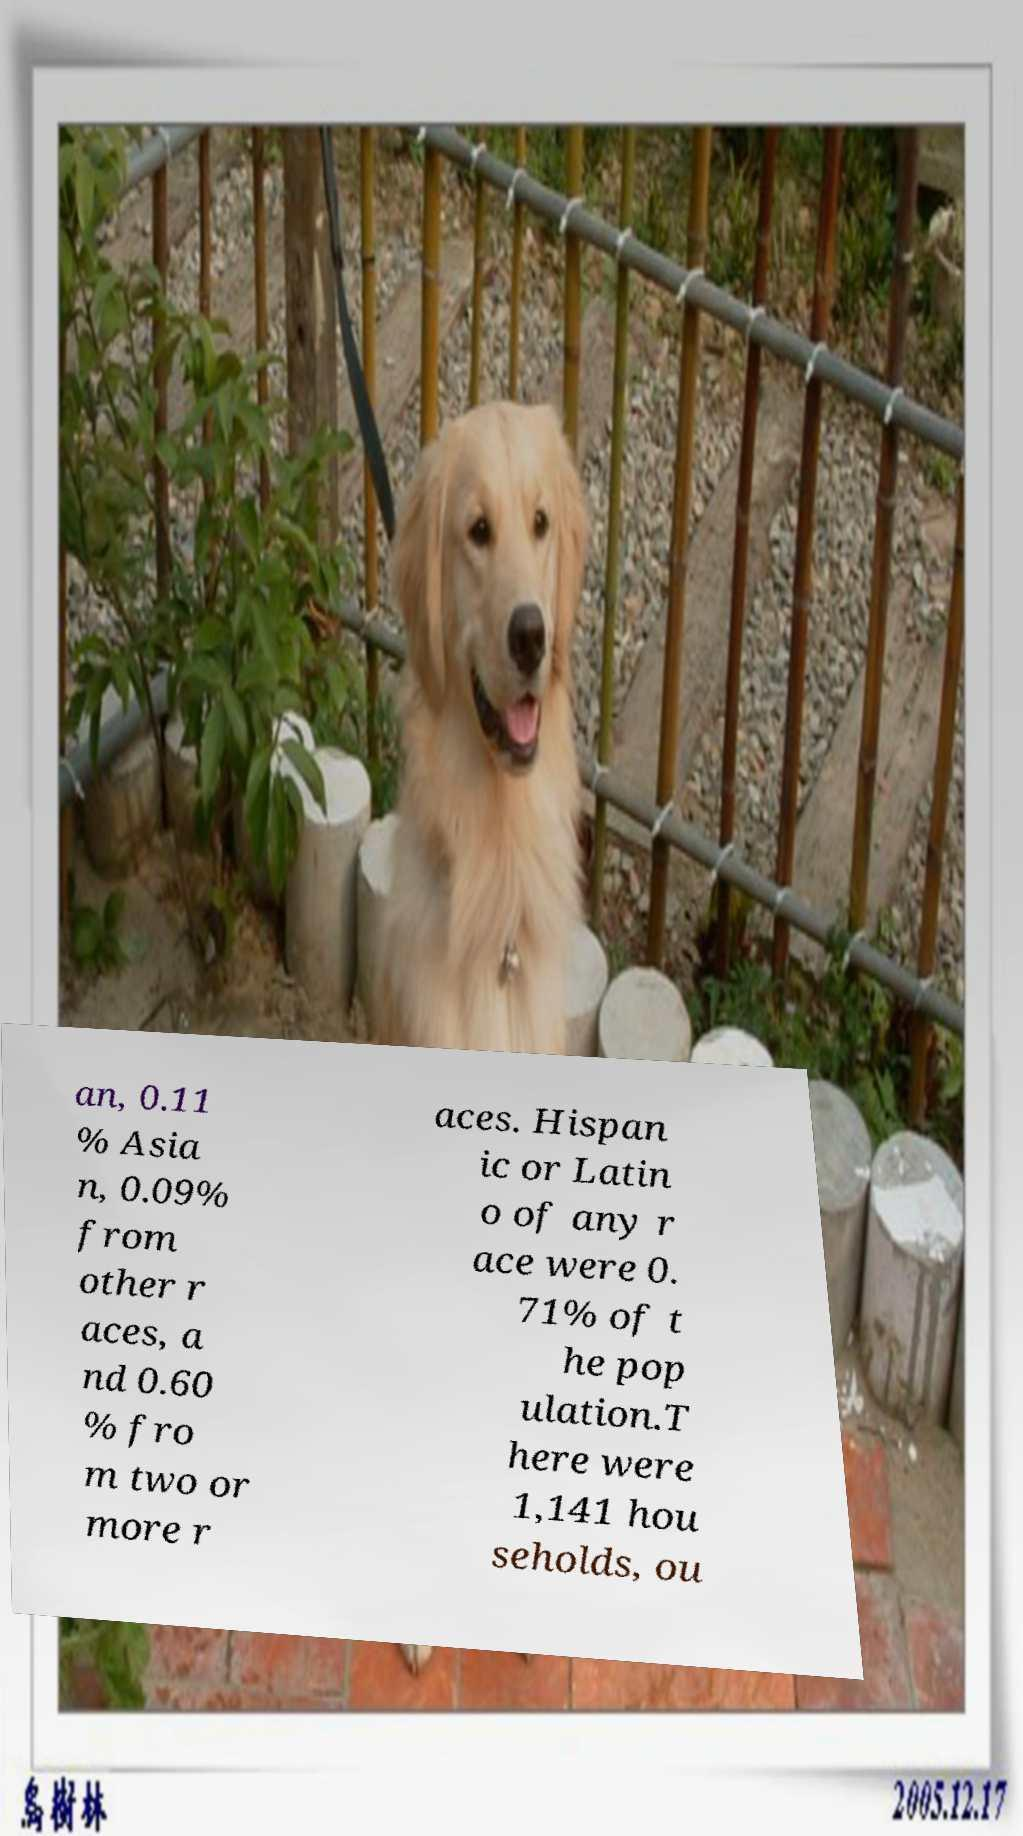Can you read and provide the text displayed in the image?This photo seems to have some interesting text. Can you extract and type it out for me? an, 0.11 % Asia n, 0.09% from other r aces, a nd 0.60 % fro m two or more r aces. Hispan ic or Latin o of any r ace were 0. 71% of t he pop ulation.T here were 1,141 hou seholds, ou 